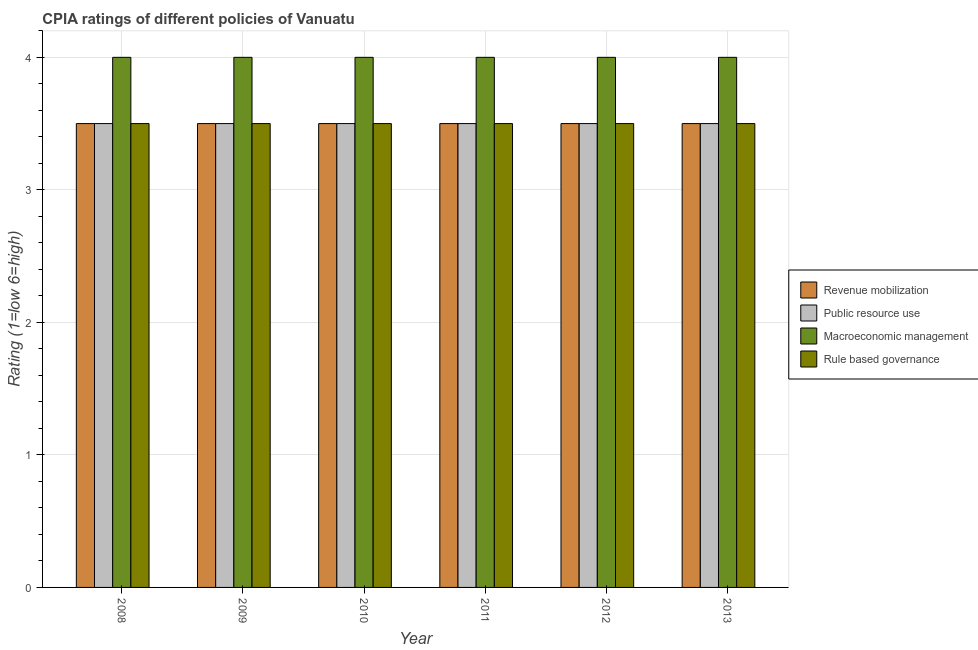How many groups of bars are there?
Offer a terse response. 6. Are the number of bars on each tick of the X-axis equal?
Your answer should be very brief. Yes. How many bars are there on the 6th tick from the left?
Offer a terse response. 4. How many bars are there on the 3rd tick from the right?
Your response must be concise. 4. What is the label of the 5th group of bars from the left?
Your answer should be very brief. 2012. In how many cases, is the number of bars for a given year not equal to the number of legend labels?
Ensure brevity in your answer.  0. In which year was the cpia rating of macroeconomic management maximum?
Make the answer very short. 2008. What is the difference between the cpia rating of public resource use in 2011 and that in 2012?
Provide a succinct answer. 0. In the year 2013, what is the difference between the cpia rating of revenue mobilization and cpia rating of macroeconomic management?
Provide a short and direct response. 0. What is the ratio of the cpia rating of revenue mobilization in 2010 to that in 2013?
Ensure brevity in your answer.  1. Is the cpia rating of macroeconomic management in 2008 less than that in 2012?
Ensure brevity in your answer.  No. Is the difference between the cpia rating of rule based governance in 2008 and 2011 greater than the difference between the cpia rating of public resource use in 2008 and 2011?
Offer a very short reply. No. Is the sum of the cpia rating of public resource use in 2011 and 2012 greater than the maximum cpia rating of rule based governance across all years?
Offer a terse response. Yes. Is it the case that in every year, the sum of the cpia rating of public resource use and cpia rating of revenue mobilization is greater than the sum of cpia rating of macroeconomic management and cpia rating of rule based governance?
Provide a succinct answer. No. What does the 4th bar from the left in 2012 represents?
Make the answer very short. Rule based governance. What does the 2nd bar from the right in 2012 represents?
Offer a very short reply. Macroeconomic management. Is it the case that in every year, the sum of the cpia rating of revenue mobilization and cpia rating of public resource use is greater than the cpia rating of macroeconomic management?
Keep it short and to the point. Yes. How many years are there in the graph?
Offer a terse response. 6. Are the values on the major ticks of Y-axis written in scientific E-notation?
Your answer should be compact. No. Where does the legend appear in the graph?
Make the answer very short. Center right. How are the legend labels stacked?
Offer a terse response. Vertical. What is the title of the graph?
Provide a succinct answer. CPIA ratings of different policies of Vanuatu. What is the Rating (1=low 6=high) of Revenue mobilization in 2008?
Provide a succinct answer. 3.5. What is the Rating (1=low 6=high) in Public resource use in 2008?
Offer a very short reply. 3.5. What is the Rating (1=low 6=high) of Macroeconomic management in 2008?
Make the answer very short. 4. What is the Rating (1=low 6=high) of Rule based governance in 2008?
Provide a short and direct response. 3.5. What is the Rating (1=low 6=high) of Revenue mobilization in 2009?
Offer a terse response. 3.5. What is the Rating (1=low 6=high) of Public resource use in 2009?
Provide a succinct answer. 3.5. What is the Rating (1=low 6=high) of Macroeconomic management in 2009?
Your answer should be very brief. 4. What is the Rating (1=low 6=high) of Revenue mobilization in 2011?
Keep it short and to the point. 3.5. What is the Rating (1=low 6=high) in Public resource use in 2011?
Your answer should be very brief. 3.5. What is the Rating (1=low 6=high) of Rule based governance in 2011?
Provide a short and direct response. 3.5. What is the Rating (1=low 6=high) in Revenue mobilization in 2012?
Your response must be concise. 3.5. What is the Rating (1=low 6=high) of Public resource use in 2012?
Keep it short and to the point. 3.5. What is the Rating (1=low 6=high) in Rule based governance in 2012?
Provide a succinct answer. 3.5. What is the Rating (1=low 6=high) of Public resource use in 2013?
Your answer should be very brief. 3.5. Across all years, what is the maximum Rating (1=low 6=high) in Revenue mobilization?
Your answer should be very brief. 3.5. Across all years, what is the maximum Rating (1=low 6=high) in Public resource use?
Offer a very short reply. 3.5. Across all years, what is the maximum Rating (1=low 6=high) of Macroeconomic management?
Give a very brief answer. 4. Across all years, what is the maximum Rating (1=low 6=high) in Rule based governance?
Give a very brief answer. 3.5. Across all years, what is the minimum Rating (1=low 6=high) in Public resource use?
Offer a terse response. 3.5. Across all years, what is the minimum Rating (1=low 6=high) of Rule based governance?
Ensure brevity in your answer.  3.5. What is the total Rating (1=low 6=high) in Revenue mobilization in the graph?
Your answer should be very brief. 21. What is the total Rating (1=low 6=high) of Public resource use in the graph?
Keep it short and to the point. 21. What is the total Rating (1=low 6=high) of Macroeconomic management in the graph?
Ensure brevity in your answer.  24. What is the difference between the Rating (1=low 6=high) of Macroeconomic management in 2008 and that in 2009?
Keep it short and to the point. 0. What is the difference between the Rating (1=low 6=high) of Revenue mobilization in 2008 and that in 2010?
Keep it short and to the point. 0. What is the difference between the Rating (1=low 6=high) of Macroeconomic management in 2008 and that in 2010?
Keep it short and to the point. 0. What is the difference between the Rating (1=low 6=high) in Public resource use in 2008 and that in 2011?
Offer a very short reply. 0. What is the difference between the Rating (1=low 6=high) in Macroeconomic management in 2008 and that in 2011?
Your response must be concise. 0. What is the difference between the Rating (1=low 6=high) in Rule based governance in 2008 and that in 2011?
Make the answer very short. 0. What is the difference between the Rating (1=low 6=high) of Macroeconomic management in 2008 and that in 2012?
Your answer should be compact. 0. What is the difference between the Rating (1=low 6=high) of Revenue mobilization in 2008 and that in 2013?
Ensure brevity in your answer.  0. What is the difference between the Rating (1=low 6=high) of Macroeconomic management in 2008 and that in 2013?
Your response must be concise. 0. What is the difference between the Rating (1=low 6=high) of Rule based governance in 2008 and that in 2013?
Your response must be concise. 0. What is the difference between the Rating (1=low 6=high) of Revenue mobilization in 2009 and that in 2011?
Offer a terse response. 0. What is the difference between the Rating (1=low 6=high) in Macroeconomic management in 2009 and that in 2011?
Provide a short and direct response. 0. What is the difference between the Rating (1=low 6=high) in Rule based governance in 2009 and that in 2011?
Keep it short and to the point. 0. What is the difference between the Rating (1=low 6=high) in Public resource use in 2009 and that in 2012?
Your answer should be compact. 0. What is the difference between the Rating (1=low 6=high) of Macroeconomic management in 2009 and that in 2012?
Your response must be concise. 0. What is the difference between the Rating (1=low 6=high) of Rule based governance in 2009 and that in 2012?
Provide a succinct answer. 0. What is the difference between the Rating (1=low 6=high) of Revenue mobilization in 2009 and that in 2013?
Your answer should be compact. 0. What is the difference between the Rating (1=low 6=high) in Public resource use in 2009 and that in 2013?
Provide a short and direct response. 0. What is the difference between the Rating (1=low 6=high) of Macroeconomic management in 2009 and that in 2013?
Make the answer very short. 0. What is the difference between the Rating (1=low 6=high) in Rule based governance in 2009 and that in 2013?
Your answer should be very brief. 0. What is the difference between the Rating (1=low 6=high) in Revenue mobilization in 2010 and that in 2011?
Keep it short and to the point. 0. What is the difference between the Rating (1=low 6=high) of Macroeconomic management in 2010 and that in 2011?
Your response must be concise. 0. What is the difference between the Rating (1=low 6=high) of Rule based governance in 2010 and that in 2011?
Give a very brief answer. 0. What is the difference between the Rating (1=low 6=high) of Public resource use in 2010 and that in 2012?
Make the answer very short. 0. What is the difference between the Rating (1=low 6=high) in Rule based governance in 2010 and that in 2012?
Offer a very short reply. 0. What is the difference between the Rating (1=low 6=high) of Macroeconomic management in 2010 and that in 2013?
Provide a short and direct response. 0. What is the difference between the Rating (1=low 6=high) of Public resource use in 2011 and that in 2012?
Provide a short and direct response. 0. What is the difference between the Rating (1=low 6=high) in Macroeconomic management in 2011 and that in 2012?
Provide a short and direct response. 0. What is the difference between the Rating (1=low 6=high) of Revenue mobilization in 2011 and that in 2013?
Offer a terse response. 0. What is the difference between the Rating (1=low 6=high) in Public resource use in 2011 and that in 2013?
Offer a very short reply. 0. What is the difference between the Rating (1=low 6=high) of Macroeconomic management in 2011 and that in 2013?
Provide a short and direct response. 0. What is the difference between the Rating (1=low 6=high) in Revenue mobilization in 2012 and that in 2013?
Make the answer very short. 0. What is the difference between the Rating (1=low 6=high) of Public resource use in 2012 and that in 2013?
Give a very brief answer. 0. What is the difference between the Rating (1=low 6=high) of Revenue mobilization in 2008 and the Rating (1=low 6=high) of Public resource use in 2009?
Give a very brief answer. 0. What is the difference between the Rating (1=low 6=high) in Public resource use in 2008 and the Rating (1=low 6=high) in Rule based governance in 2010?
Give a very brief answer. 0. What is the difference between the Rating (1=low 6=high) in Macroeconomic management in 2008 and the Rating (1=low 6=high) in Rule based governance in 2010?
Provide a short and direct response. 0.5. What is the difference between the Rating (1=low 6=high) in Revenue mobilization in 2008 and the Rating (1=low 6=high) in Macroeconomic management in 2011?
Give a very brief answer. -0.5. What is the difference between the Rating (1=low 6=high) of Macroeconomic management in 2008 and the Rating (1=low 6=high) of Rule based governance in 2011?
Your response must be concise. 0.5. What is the difference between the Rating (1=low 6=high) in Public resource use in 2008 and the Rating (1=low 6=high) in Macroeconomic management in 2012?
Give a very brief answer. -0.5. What is the difference between the Rating (1=low 6=high) in Public resource use in 2008 and the Rating (1=low 6=high) in Rule based governance in 2012?
Your answer should be compact. 0. What is the difference between the Rating (1=low 6=high) in Revenue mobilization in 2008 and the Rating (1=low 6=high) in Public resource use in 2013?
Make the answer very short. 0. What is the difference between the Rating (1=low 6=high) in Revenue mobilization in 2008 and the Rating (1=low 6=high) in Macroeconomic management in 2013?
Your response must be concise. -0.5. What is the difference between the Rating (1=low 6=high) of Revenue mobilization in 2008 and the Rating (1=low 6=high) of Rule based governance in 2013?
Keep it short and to the point. 0. What is the difference between the Rating (1=low 6=high) of Public resource use in 2008 and the Rating (1=low 6=high) of Macroeconomic management in 2013?
Ensure brevity in your answer.  -0.5. What is the difference between the Rating (1=low 6=high) in Public resource use in 2008 and the Rating (1=low 6=high) in Rule based governance in 2013?
Make the answer very short. 0. What is the difference between the Rating (1=low 6=high) of Macroeconomic management in 2008 and the Rating (1=low 6=high) of Rule based governance in 2013?
Offer a very short reply. 0.5. What is the difference between the Rating (1=low 6=high) in Revenue mobilization in 2009 and the Rating (1=low 6=high) in Public resource use in 2010?
Give a very brief answer. 0. What is the difference between the Rating (1=low 6=high) of Public resource use in 2009 and the Rating (1=low 6=high) of Macroeconomic management in 2010?
Offer a terse response. -0.5. What is the difference between the Rating (1=low 6=high) in Public resource use in 2009 and the Rating (1=low 6=high) in Rule based governance in 2010?
Your response must be concise. 0. What is the difference between the Rating (1=low 6=high) in Macroeconomic management in 2009 and the Rating (1=low 6=high) in Rule based governance in 2010?
Make the answer very short. 0.5. What is the difference between the Rating (1=low 6=high) in Revenue mobilization in 2009 and the Rating (1=low 6=high) in Rule based governance in 2011?
Your answer should be compact. 0. What is the difference between the Rating (1=low 6=high) in Public resource use in 2009 and the Rating (1=low 6=high) in Rule based governance in 2011?
Your response must be concise. 0. What is the difference between the Rating (1=low 6=high) of Revenue mobilization in 2009 and the Rating (1=low 6=high) of Public resource use in 2012?
Your response must be concise. 0. What is the difference between the Rating (1=low 6=high) of Revenue mobilization in 2009 and the Rating (1=low 6=high) of Macroeconomic management in 2012?
Your answer should be very brief. -0.5. What is the difference between the Rating (1=low 6=high) in Macroeconomic management in 2009 and the Rating (1=low 6=high) in Rule based governance in 2012?
Give a very brief answer. 0.5. What is the difference between the Rating (1=low 6=high) of Revenue mobilization in 2009 and the Rating (1=low 6=high) of Macroeconomic management in 2013?
Your answer should be very brief. -0.5. What is the difference between the Rating (1=low 6=high) in Public resource use in 2009 and the Rating (1=low 6=high) in Rule based governance in 2013?
Keep it short and to the point. 0. What is the difference between the Rating (1=low 6=high) of Public resource use in 2010 and the Rating (1=low 6=high) of Macroeconomic management in 2011?
Offer a terse response. -0.5. What is the difference between the Rating (1=low 6=high) in Public resource use in 2010 and the Rating (1=low 6=high) in Rule based governance in 2011?
Provide a succinct answer. 0. What is the difference between the Rating (1=low 6=high) of Public resource use in 2010 and the Rating (1=low 6=high) of Macroeconomic management in 2012?
Offer a terse response. -0.5. What is the difference between the Rating (1=low 6=high) of Public resource use in 2010 and the Rating (1=low 6=high) of Rule based governance in 2012?
Make the answer very short. 0. What is the difference between the Rating (1=low 6=high) of Macroeconomic management in 2010 and the Rating (1=low 6=high) of Rule based governance in 2012?
Your answer should be very brief. 0.5. What is the difference between the Rating (1=low 6=high) of Revenue mobilization in 2010 and the Rating (1=low 6=high) of Rule based governance in 2013?
Offer a terse response. 0. What is the difference between the Rating (1=low 6=high) of Public resource use in 2010 and the Rating (1=low 6=high) of Rule based governance in 2013?
Provide a short and direct response. 0. What is the difference between the Rating (1=low 6=high) in Macroeconomic management in 2010 and the Rating (1=low 6=high) in Rule based governance in 2013?
Make the answer very short. 0.5. What is the difference between the Rating (1=low 6=high) in Revenue mobilization in 2011 and the Rating (1=low 6=high) in Macroeconomic management in 2012?
Ensure brevity in your answer.  -0.5. What is the difference between the Rating (1=low 6=high) in Public resource use in 2011 and the Rating (1=low 6=high) in Rule based governance in 2012?
Your response must be concise. 0. What is the difference between the Rating (1=low 6=high) of Macroeconomic management in 2011 and the Rating (1=low 6=high) of Rule based governance in 2012?
Keep it short and to the point. 0.5. What is the difference between the Rating (1=low 6=high) of Revenue mobilization in 2011 and the Rating (1=low 6=high) of Public resource use in 2013?
Make the answer very short. 0. What is the difference between the Rating (1=low 6=high) in Revenue mobilization in 2011 and the Rating (1=low 6=high) in Macroeconomic management in 2013?
Offer a terse response. -0.5. What is the difference between the Rating (1=low 6=high) of Revenue mobilization in 2011 and the Rating (1=low 6=high) of Rule based governance in 2013?
Ensure brevity in your answer.  0. What is the difference between the Rating (1=low 6=high) of Public resource use in 2011 and the Rating (1=low 6=high) of Rule based governance in 2013?
Provide a succinct answer. 0. What is the difference between the Rating (1=low 6=high) in Macroeconomic management in 2011 and the Rating (1=low 6=high) in Rule based governance in 2013?
Provide a short and direct response. 0.5. What is the difference between the Rating (1=low 6=high) of Revenue mobilization in 2012 and the Rating (1=low 6=high) of Rule based governance in 2013?
Provide a short and direct response. 0. What is the difference between the Rating (1=low 6=high) of Public resource use in 2012 and the Rating (1=low 6=high) of Macroeconomic management in 2013?
Keep it short and to the point. -0.5. What is the difference between the Rating (1=low 6=high) of Macroeconomic management in 2012 and the Rating (1=low 6=high) of Rule based governance in 2013?
Your response must be concise. 0.5. What is the average Rating (1=low 6=high) in Rule based governance per year?
Offer a terse response. 3.5. In the year 2008, what is the difference between the Rating (1=low 6=high) of Revenue mobilization and Rating (1=low 6=high) of Macroeconomic management?
Your response must be concise. -0.5. In the year 2008, what is the difference between the Rating (1=low 6=high) in Revenue mobilization and Rating (1=low 6=high) in Rule based governance?
Make the answer very short. 0. In the year 2008, what is the difference between the Rating (1=low 6=high) of Public resource use and Rating (1=low 6=high) of Rule based governance?
Offer a terse response. 0. In the year 2008, what is the difference between the Rating (1=low 6=high) of Macroeconomic management and Rating (1=low 6=high) of Rule based governance?
Provide a short and direct response. 0.5. In the year 2009, what is the difference between the Rating (1=low 6=high) of Revenue mobilization and Rating (1=low 6=high) of Public resource use?
Keep it short and to the point. 0. In the year 2009, what is the difference between the Rating (1=low 6=high) in Revenue mobilization and Rating (1=low 6=high) in Macroeconomic management?
Provide a short and direct response. -0.5. In the year 2009, what is the difference between the Rating (1=low 6=high) in Public resource use and Rating (1=low 6=high) in Macroeconomic management?
Your answer should be very brief. -0.5. In the year 2010, what is the difference between the Rating (1=low 6=high) of Revenue mobilization and Rating (1=low 6=high) of Macroeconomic management?
Give a very brief answer. -0.5. In the year 2010, what is the difference between the Rating (1=low 6=high) in Revenue mobilization and Rating (1=low 6=high) in Rule based governance?
Keep it short and to the point. 0. In the year 2011, what is the difference between the Rating (1=low 6=high) in Revenue mobilization and Rating (1=low 6=high) in Macroeconomic management?
Your response must be concise. -0.5. In the year 2011, what is the difference between the Rating (1=low 6=high) of Public resource use and Rating (1=low 6=high) of Macroeconomic management?
Keep it short and to the point. -0.5. In the year 2011, what is the difference between the Rating (1=low 6=high) of Public resource use and Rating (1=low 6=high) of Rule based governance?
Your answer should be compact. 0. In the year 2011, what is the difference between the Rating (1=low 6=high) of Macroeconomic management and Rating (1=low 6=high) of Rule based governance?
Your response must be concise. 0.5. In the year 2012, what is the difference between the Rating (1=low 6=high) of Revenue mobilization and Rating (1=low 6=high) of Public resource use?
Your answer should be compact. 0. In the year 2012, what is the difference between the Rating (1=low 6=high) in Public resource use and Rating (1=low 6=high) in Rule based governance?
Keep it short and to the point. 0. In the year 2013, what is the difference between the Rating (1=low 6=high) of Revenue mobilization and Rating (1=low 6=high) of Rule based governance?
Offer a terse response. 0. In the year 2013, what is the difference between the Rating (1=low 6=high) of Public resource use and Rating (1=low 6=high) of Macroeconomic management?
Your response must be concise. -0.5. In the year 2013, what is the difference between the Rating (1=low 6=high) in Macroeconomic management and Rating (1=low 6=high) in Rule based governance?
Ensure brevity in your answer.  0.5. What is the ratio of the Rating (1=low 6=high) of Macroeconomic management in 2008 to that in 2009?
Provide a short and direct response. 1. What is the ratio of the Rating (1=low 6=high) of Revenue mobilization in 2008 to that in 2010?
Your answer should be very brief. 1. What is the ratio of the Rating (1=low 6=high) of Revenue mobilization in 2008 to that in 2012?
Ensure brevity in your answer.  1. What is the ratio of the Rating (1=low 6=high) of Public resource use in 2008 to that in 2012?
Your answer should be compact. 1. What is the ratio of the Rating (1=low 6=high) of Revenue mobilization in 2008 to that in 2013?
Give a very brief answer. 1. What is the ratio of the Rating (1=low 6=high) of Rule based governance in 2008 to that in 2013?
Provide a short and direct response. 1. What is the ratio of the Rating (1=low 6=high) in Public resource use in 2009 to that in 2010?
Offer a very short reply. 1. What is the ratio of the Rating (1=low 6=high) in Macroeconomic management in 2009 to that in 2010?
Provide a succinct answer. 1. What is the ratio of the Rating (1=low 6=high) in Rule based governance in 2009 to that in 2010?
Your answer should be very brief. 1. What is the ratio of the Rating (1=low 6=high) of Revenue mobilization in 2009 to that in 2011?
Keep it short and to the point. 1. What is the ratio of the Rating (1=low 6=high) in Macroeconomic management in 2009 to that in 2013?
Provide a succinct answer. 1. What is the ratio of the Rating (1=low 6=high) of Rule based governance in 2009 to that in 2013?
Provide a succinct answer. 1. What is the ratio of the Rating (1=low 6=high) in Revenue mobilization in 2010 to that in 2011?
Your response must be concise. 1. What is the ratio of the Rating (1=low 6=high) of Rule based governance in 2010 to that in 2011?
Your response must be concise. 1. What is the ratio of the Rating (1=low 6=high) in Macroeconomic management in 2010 to that in 2012?
Your answer should be compact. 1. What is the ratio of the Rating (1=low 6=high) of Revenue mobilization in 2010 to that in 2013?
Make the answer very short. 1. What is the ratio of the Rating (1=low 6=high) of Rule based governance in 2010 to that in 2013?
Make the answer very short. 1. What is the ratio of the Rating (1=low 6=high) of Revenue mobilization in 2011 to that in 2012?
Offer a very short reply. 1. What is the ratio of the Rating (1=low 6=high) in Revenue mobilization in 2011 to that in 2013?
Offer a terse response. 1. What is the ratio of the Rating (1=low 6=high) of Public resource use in 2011 to that in 2013?
Offer a terse response. 1. What is the ratio of the Rating (1=low 6=high) of Public resource use in 2012 to that in 2013?
Ensure brevity in your answer.  1. What is the ratio of the Rating (1=low 6=high) of Macroeconomic management in 2012 to that in 2013?
Give a very brief answer. 1. What is the ratio of the Rating (1=low 6=high) of Rule based governance in 2012 to that in 2013?
Make the answer very short. 1. What is the difference between the highest and the second highest Rating (1=low 6=high) in Public resource use?
Make the answer very short. 0. What is the difference between the highest and the second highest Rating (1=low 6=high) of Macroeconomic management?
Your response must be concise. 0. What is the difference between the highest and the second highest Rating (1=low 6=high) of Rule based governance?
Provide a succinct answer. 0. What is the difference between the highest and the lowest Rating (1=low 6=high) of Revenue mobilization?
Make the answer very short. 0. What is the difference between the highest and the lowest Rating (1=low 6=high) in Public resource use?
Make the answer very short. 0. What is the difference between the highest and the lowest Rating (1=low 6=high) of Rule based governance?
Make the answer very short. 0. 